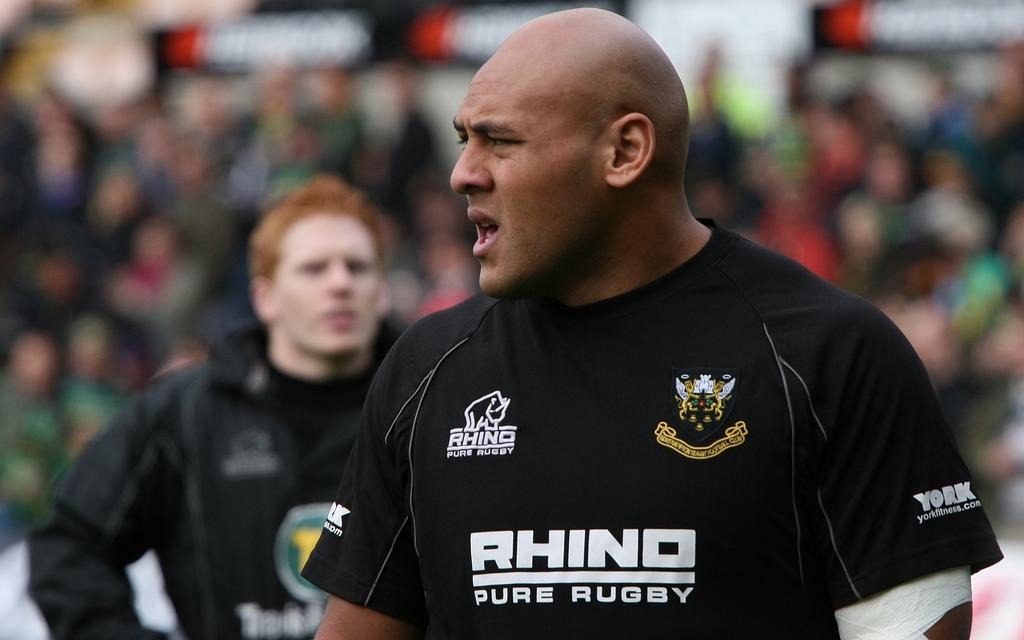<image>
Write a terse but informative summary of the picture. a Rhino Sure Rugby shirt on this man. 